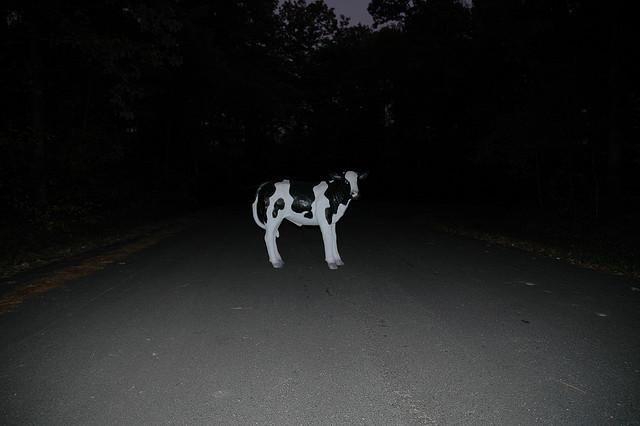Does this animal have claws?
Keep it brief. No. What is the scientific name for this animal?
Short answer required. Cow. Do you see a branch on the ground?
Quick response, please. No. How many animals are shown?
Concise answer only. 1. What animal is in this photo?
Be succinct. Cow. Is there a rainbow?
Keep it brief. No. What type of room is this?
Be succinct. Outside. Is this cat a tiger cat?
Be succinct. No. Is this cow standing in the grass?
Be succinct. No. What is causing the shadow?
Quick response, please. Cow. Is this a zoo?
Concise answer only. No. Could this be a traffic hazard?
Keep it brief. Yes. What time of day is it?
Short answer required. Night. Are there any animals in the scene?
Answer briefly. Yes. Is the cow real?
Concise answer only. Yes. What animal is this?
Concise answer only. Cow. Is this picture taken during the daytime?
Concise answer only. No. Is this a real cow?
Give a very brief answer. No. Is the ground damp?
Quick response, please. No. Is this a duck?
Quick response, please. No. What kind of animal is this?
Be succinct. Cow. What is. The animal?
Be succinct. Cow. Is the cow looking for food?
Be succinct. No. 